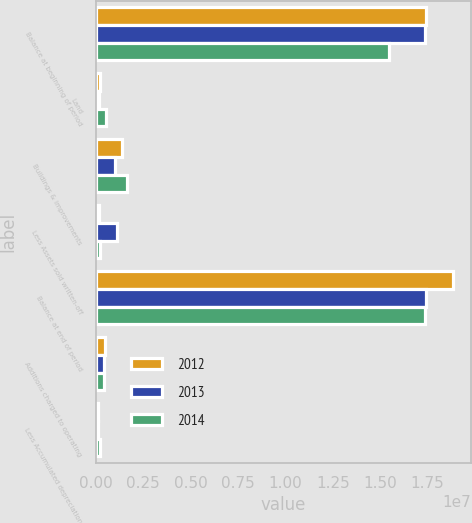Convert chart. <chart><loc_0><loc_0><loc_500><loc_500><stacked_bar_chart><ecel><fcel>Balance at beginning of period<fcel>Land<fcel>Buildings & improvements<fcel>Less Assets sold written-off<fcel>Balance at end of period<fcel>Additions charged to operating<fcel>Less Accumulated depreciation<nl><fcel>2012<fcel>1.74189e+07<fcel>225536<fcel>1.34815e+06<fcel>147243<fcel>1.88454e+07<fcel>461689<fcel>129271<nl><fcel>2013<fcel>1.73655e+07<fcel>131646<fcel>1.01488e+06<fcel>1.09311e+06<fcel>1.74189e+07<fcel>423844<fcel>93194<nl><fcel>2014<fcel>1.54448e+07<fcel>514950<fcel>1.61508e+06<fcel>209248<fcel>1.73655e+07<fcel>427189<fcel>203366<nl></chart> 